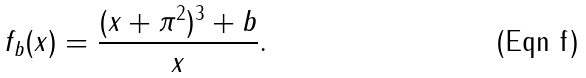Convert formula to latex. <formula><loc_0><loc_0><loc_500><loc_500>f _ { b } ( x ) = \frac { ( x + \pi ^ { 2 } ) ^ { 3 } + b } { x } .</formula> 